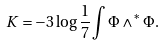<formula> <loc_0><loc_0><loc_500><loc_500>K = - 3 \log \frac { 1 } { 7 } \int \Phi \wedge ^ { * } \Phi .</formula> 